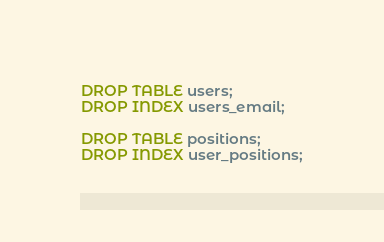Convert code to text. <code><loc_0><loc_0><loc_500><loc_500><_SQL_>DROP TABLE users;
DROP INDEX users_email;

DROP TABLE positions;
DROP INDEX user_positions;
</code> 